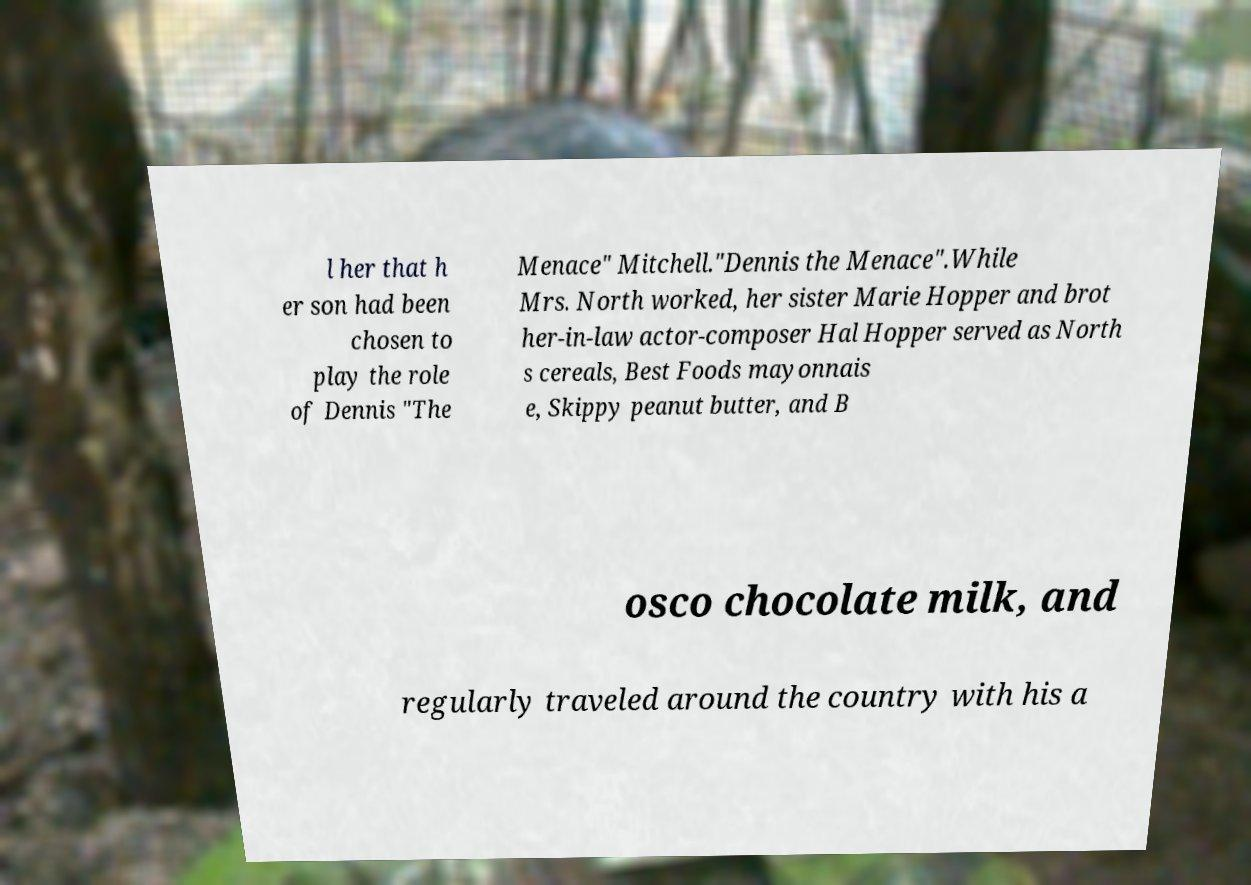Can you accurately transcribe the text from the provided image for me? l her that h er son had been chosen to play the role of Dennis "The Menace" Mitchell."Dennis the Menace".While Mrs. North worked, her sister Marie Hopper and brot her-in-law actor-composer Hal Hopper served as North s cereals, Best Foods mayonnais e, Skippy peanut butter, and B osco chocolate milk, and regularly traveled around the country with his a 